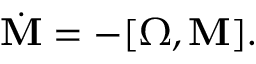<formula> <loc_0><loc_0><loc_500><loc_500>\begin{array} { r } { \dot { M } = - [ { \boldsymbol \Omega } , { M } ] . } \end{array}</formula> 